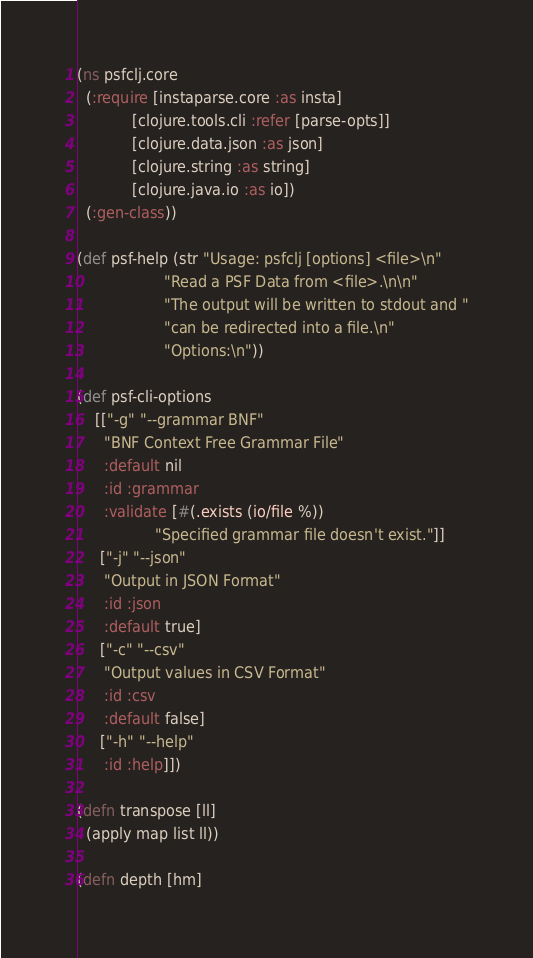Convert code to text. <code><loc_0><loc_0><loc_500><loc_500><_Clojure_>(ns psfclj.core
  (:require [instaparse.core :as insta]
            [clojure.tools.cli :refer [parse-opts]]
            [clojure.data.json :as json]
            [clojure.string :as string]
            [clojure.java.io :as io])
  (:gen-class))

(def psf-help (str "Usage: psfclj [options] <file>\n"
                   "Read a PSF Data from <file>.\n\n"
                   "The output will be written to stdout and "
                   "can be redirected into a file.\n"
                   "Options:\n"))

(def psf-cli-options
    [["-g" "--grammar BNF" 
      "BNF Context Free Grammar File"
      :default nil
      :id :grammar
      :validate [#(.exists (io/file %))
                 "Specified grammar file doesn't exist."]]
     ["-j" "--json"
      "Output in JSON Format"
      :id :json
      :default true]
     ["-c" "--csv"
      "Output values in CSV Format"
      :id :csv
      :default false]
     ["-h" "--help"
      :id :help]])

(defn transpose [ll]
  (apply map list ll))

(defn depth [hm]</code> 